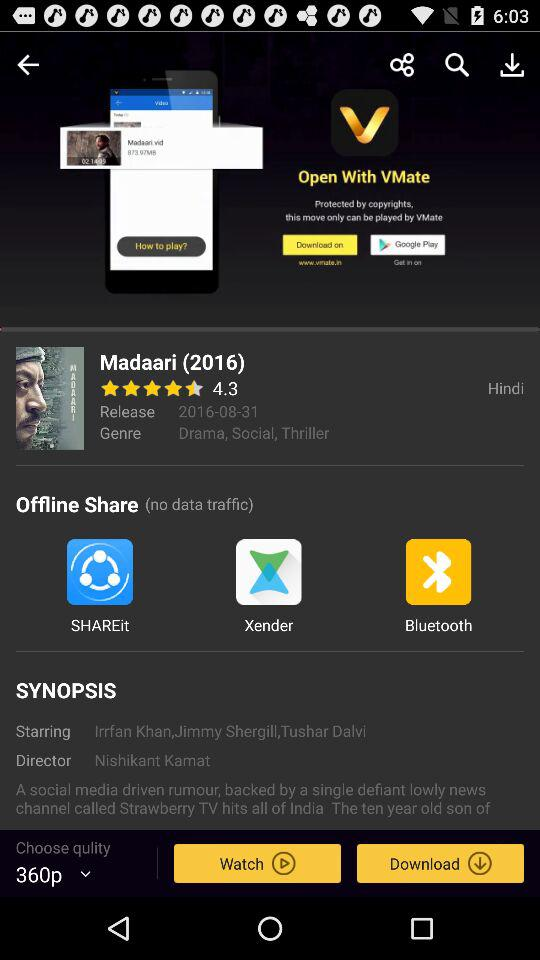What is the language of the movie? The language of the movie is Hindi. 